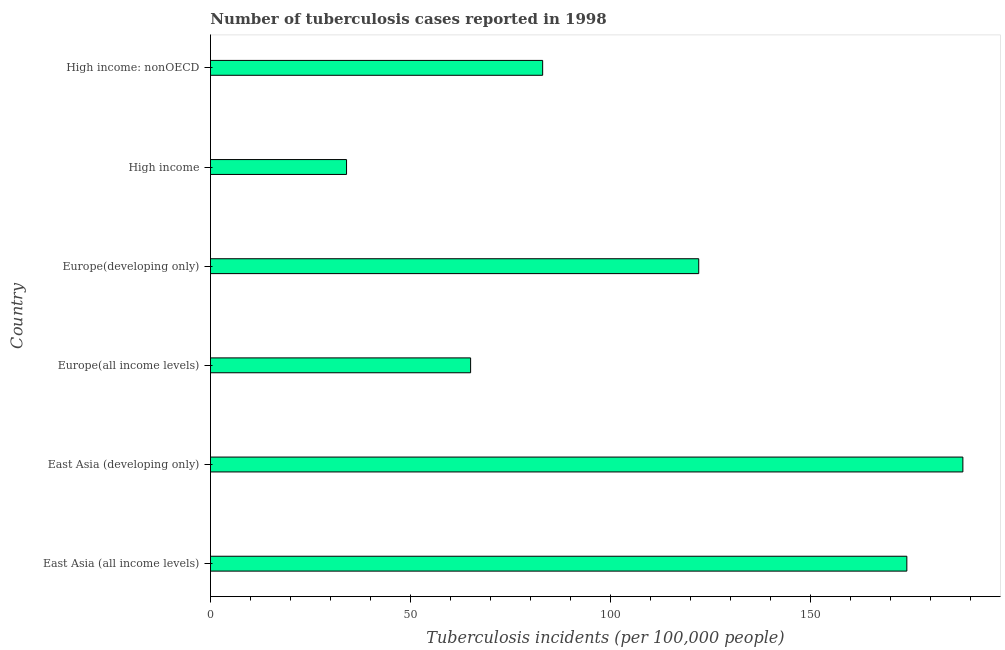What is the title of the graph?
Offer a terse response. Number of tuberculosis cases reported in 1998. What is the label or title of the X-axis?
Your response must be concise. Tuberculosis incidents (per 100,0 people). What is the label or title of the Y-axis?
Provide a short and direct response. Country. What is the number of tuberculosis incidents in Europe(developing only)?
Provide a short and direct response. 122. Across all countries, what is the maximum number of tuberculosis incidents?
Give a very brief answer. 188. In which country was the number of tuberculosis incidents maximum?
Keep it short and to the point. East Asia (developing only). What is the sum of the number of tuberculosis incidents?
Offer a very short reply. 666. What is the difference between the number of tuberculosis incidents in High income and High income: nonOECD?
Your answer should be very brief. -49. What is the average number of tuberculosis incidents per country?
Your answer should be compact. 111. What is the median number of tuberculosis incidents?
Provide a short and direct response. 102.5. In how many countries, is the number of tuberculosis incidents greater than 80 ?
Provide a short and direct response. 4. What is the ratio of the number of tuberculosis incidents in East Asia (all income levels) to that in East Asia (developing only)?
Give a very brief answer. 0.93. Is the difference between the number of tuberculosis incidents in East Asia (all income levels) and Europe(all income levels) greater than the difference between any two countries?
Your response must be concise. No. What is the difference between the highest and the second highest number of tuberculosis incidents?
Give a very brief answer. 14. Is the sum of the number of tuberculosis incidents in East Asia (developing only) and High income: nonOECD greater than the maximum number of tuberculosis incidents across all countries?
Offer a terse response. Yes. What is the difference between the highest and the lowest number of tuberculosis incidents?
Give a very brief answer. 154. In how many countries, is the number of tuberculosis incidents greater than the average number of tuberculosis incidents taken over all countries?
Ensure brevity in your answer.  3. What is the Tuberculosis incidents (per 100,000 people) of East Asia (all income levels)?
Make the answer very short. 174. What is the Tuberculosis incidents (per 100,000 people) in East Asia (developing only)?
Your answer should be compact. 188. What is the Tuberculosis incidents (per 100,000 people) of Europe(developing only)?
Make the answer very short. 122. What is the Tuberculosis incidents (per 100,000 people) in High income?
Provide a short and direct response. 34. What is the difference between the Tuberculosis incidents (per 100,000 people) in East Asia (all income levels) and Europe(all income levels)?
Provide a short and direct response. 109. What is the difference between the Tuberculosis incidents (per 100,000 people) in East Asia (all income levels) and Europe(developing only)?
Offer a very short reply. 52. What is the difference between the Tuberculosis incidents (per 100,000 people) in East Asia (all income levels) and High income?
Provide a succinct answer. 140. What is the difference between the Tuberculosis incidents (per 100,000 people) in East Asia (all income levels) and High income: nonOECD?
Give a very brief answer. 91. What is the difference between the Tuberculosis incidents (per 100,000 people) in East Asia (developing only) and Europe(all income levels)?
Offer a very short reply. 123. What is the difference between the Tuberculosis incidents (per 100,000 people) in East Asia (developing only) and Europe(developing only)?
Your response must be concise. 66. What is the difference between the Tuberculosis incidents (per 100,000 people) in East Asia (developing only) and High income?
Ensure brevity in your answer.  154. What is the difference between the Tuberculosis incidents (per 100,000 people) in East Asia (developing only) and High income: nonOECD?
Your response must be concise. 105. What is the difference between the Tuberculosis incidents (per 100,000 people) in Europe(all income levels) and Europe(developing only)?
Your answer should be very brief. -57. What is the difference between the Tuberculosis incidents (per 100,000 people) in Europe(developing only) and High income?
Give a very brief answer. 88. What is the difference between the Tuberculosis incidents (per 100,000 people) in High income and High income: nonOECD?
Ensure brevity in your answer.  -49. What is the ratio of the Tuberculosis incidents (per 100,000 people) in East Asia (all income levels) to that in East Asia (developing only)?
Provide a short and direct response. 0.93. What is the ratio of the Tuberculosis incidents (per 100,000 people) in East Asia (all income levels) to that in Europe(all income levels)?
Provide a succinct answer. 2.68. What is the ratio of the Tuberculosis incidents (per 100,000 people) in East Asia (all income levels) to that in Europe(developing only)?
Your response must be concise. 1.43. What is the ratio of the Tuberculosis incidents (per 100,000 people) in East Asia (all income levels) to that in High income?
Keep it short and to the point. 5.12. What is the ratio of the Tuberculosis incidents (per 100,000 people) in East Asia (all income levels) to that in High income: nonOECD?
Provide a short and direct response. 2.1. What is the ratio of the Tuberculosis incidents (per 100,000 people) in East Asia (developing only) to that in Europe(all income levels)?
Offer a very short reply. 2.89. What is the ratio of the Tuberculosis incidents (per 100,000 people) in East Asia (developing only) to that in Europe(developing only)?
Your answer should be compact. 1.54. What is the ratio of the Tuberculosis incidents (per 100,000 people) in East Asia (developing only) to that in High income?
Give a very brief answer. 5.53. What is the ratio of the Tuberculosis incidents (per 100,000 people) in East Asia (developing only) to that in High income: nonOECD?
Your response must be concise. 2.27. What is the ratio of the Tuberculosis incidents (per 100,000 people) in Europe(all income levels) to that in Europe(developing only)?
Make the answer very short. 0.53. What is the ratio of the Tuberculosis incidents (per 100,000 people) in Europe(all income levels) to that in High income?
Your answer should be very brief. 1.91. What is the ratio of the Tuberculosis incidents (per 100,000 people) in Europe(all income levels) to that in High income: nonOECD?
Provide a short and direct response. 0.78. What is the ratio of the Tuberculosis incidents (per 100,000 people) in Europe(developing only) to that in High income?
Give a very brief answer. 3.59. What is the ratio of the Tuberculosis incidents (per 100,000 people) in Europe(developing only) to that in High income: nonOECD?
Offer a terse response. 1.47. What is the ratio of the Tuberculosis incidents (per 100,000 people) in High income to that in High income: nonOECD?
Provide a short and direct response. 0.41. 